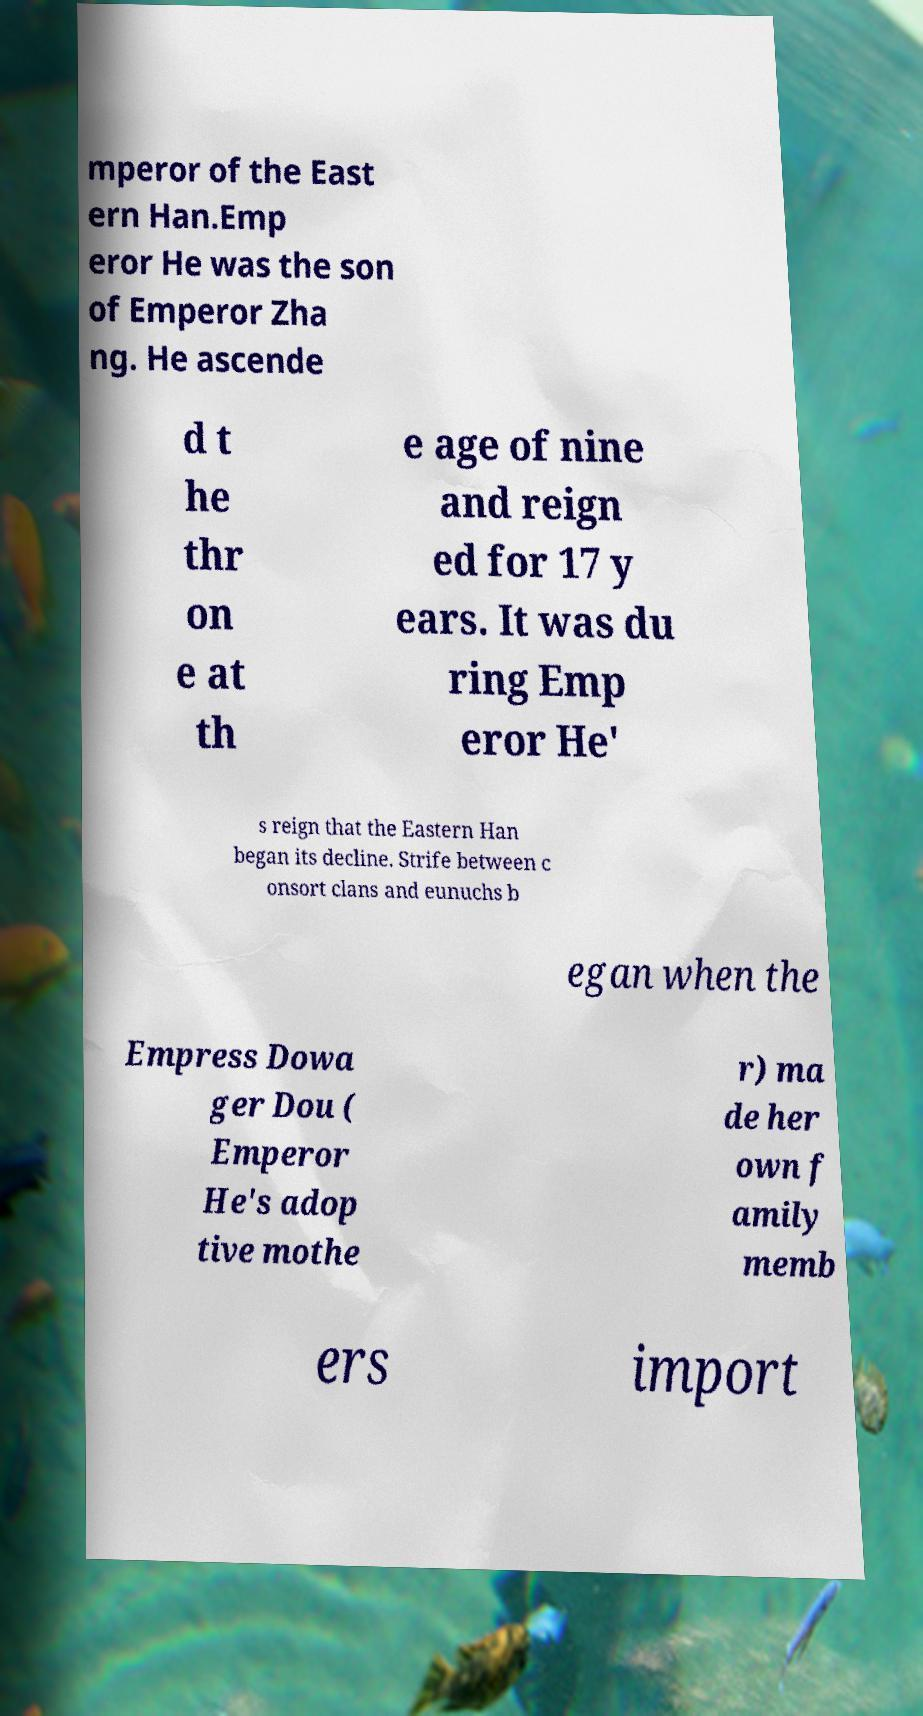Please identify and transcribe the text found in this image. mperor of the East ern Han.Emp eror He was the son of Emperor Zha ng. He ascende d t he thr on e at th e age of nine and reign ed for 17 y ears. It was du ring Emp eror He' s reign that the Eastern Han began its decline. Strife between c onsort clans and eunuchs b egan when the Empress Dowa ger Dou ( Emperor He's adop tive mothe r) ma de her own f amily memb ers import 